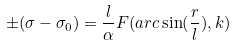<formula> <loc_0><loc_0><loc_500><loc_500>\pm ( \sigma - \sigma _ { 0 } ) = \frac { l } { \alpha } F ( a r c \sin ( \frac { r } { l } ) , k )</formula> 